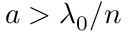Convert formula to latex. <formula><loc_0><loc_0><loc_500><loc_500>a > \lambda _ { 0 } / n</formula> 